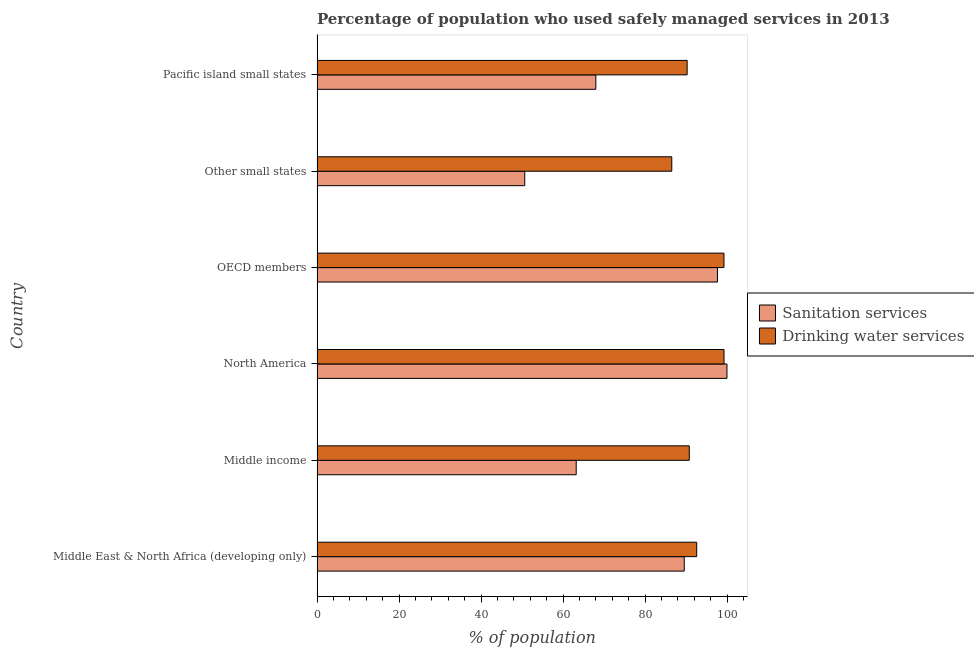How many different coloured bars are there?
Give a very brief answer. 2. How many groups of bars are there?
Your answer should be compact. 6. How many bars are there on the 5th tick from the top?
Keep it short and to the point. 2. What is the percentage of population who used drinking water services in Middle East & North Africa (developing only)?
Offer a terse response. 92.6. Across all countries, what is the maximum percentage of population who used sanitation services?
Your answer should be compact. 99.98. Across all countries, what is the minimum percentage of population who used drinking water services?
Your answer should be compact. 86.52. In which country was the percentage of population who used sanitation services maximum?
Give a very brief answer. North America. In which country was the percentage of population who used sanitation services minimum?
Ensure brevity in your answer.  Other small states. What is the total percentage of population who used drinking water services in the graph?
Your answer should be compact. 558.68. What is the difference between the percentage of population who used drinking water services in Middle income and that in Other small states?
Your response must be concise. 4.27. What is the difference between the percentage of population who used sanitation services in Middle income and the percentage of population who used drinking water services in Middle East & North Africa (developing only)?
Provide a short and direct response. -29.39. What is the average percentage of population who used sanitation services per country?
Offer a terse response. 78.18. What is the difference between the percentage of population who used drinking water services and percentage of population who used sanitation services in Middle East & North Africa (developing only)?
Make the answer very short. 3.03. What is the ratio of the percentage of population who used drinking water services in North America to that in Other small states?
Your answer should be very brief. 1.15. Is the percentage of population who used drinking water services in OECD members less than that in Other small states?
Keep it short and to the point. No. What is the difference between the highest and the second highest percentage of population who used drinking water services?
Offer a terse response. 0.02. What is the difference between the highest and the lowest percentage of population who used sanitation services?
Ensure brevity in your answer.  49.32. Is the sum of the percentage of population who used sanitation services in OECD members and Pacific island small states greater than the maximum percentage of population who used drinking water services across all countries?
Offer a terse response. Yes. What does the 2nd bar from the top in Middle income represents?
Offer a terse response. Sanitation services. What does the 2nd bar from the bottom in OECD members represents?
Offer a terse response. Drinking water services. How many countries are there in the graph?
Provide a short and direct response. 6. Does the graph contain any zero values?
Give a very brief answer. No. Does the graph contain grids?
Make the answer very short. No. Where does the legend appear in the graph?
Give a very brief answer. Center right. How are the legend labels stacked?
Provide a succinct answer. Vertical. What is the title of the graph?
Ensure brevity in your answer.  Percentage of population who used safely managed services in 2013. What is the label or title of the X-axis?
Offer a terse response. % of population. What is the label or title of the Y-axis?
Your answer should be very brief. Country. What is the % of population of Sanitation services in Middle East & North Africa (developing only)?
Your response must be concise. 89.57. What is the % of population of Drinking water services in Middle East & North Africa (developing only)?
Make the answer very short. 92.6. What is the % of population of Sanitation services in Middle income?
Offer a terse response. 63.21. What is the % of population in Drinking water services in Middle income?
Your response must be concise. 90.79. What is the % of population of Sanitation services in North America?
Offer a very short reply. 99.98. What is the % of population of Drinking water services in North America?
Ensure brevity in your answer.  99.26. What is the % of population of Sanitation services in OECD members?
Provide a succinct answer. 97.66. What is the % of population of Drinking water services in OECD members?
Give a very brief answer. 99.24. What is the % of population of Sanitation services in Other small states?
Your answer should be very brief. 50.66. What is the % of population of Drinking water services in Other small states?
Your response must be concise. 86.52. What is the % of population of Sanitation services in Pacific island small states?
Your answer should be compact. 68. What is the % of population of Drinking water services in Pacific island small states?
Give a very brief answer. 90.27. Across all countries, what is the maximum % of population in Sanitation services?
Keep it short and to the point. 99.98. Across all countries, what is the maximum % of population of Drinking water services?
Your response must be concise. 99.26. Across all countries, what is the minimum % of population of Sanitation services?
Give a very brief answer. 50.66. Across all countries, what is the minimum % of population of Drinking water services?
Provide a short and direct response. 86.52. What is the total % of population in Sanitation services in the graph?
Offer a very short reply. 469.07. What is the total % of population of Drinking water services in the graph?
Keep it short and to the point. 558.68. What is the difference between the % of population of Sanitation services in Middle East & North Africa (developing only) and that in Middle income?
Your answer should be very brief. 26.36. What is the difference between the % of population of Drinking water services in Middle East & North Africa (developing only) and that in Middle income?
Your answer should be compact. 1.81. What is the difference between the % of population of Sanitation services in Middle East & North Africa (developing only) and that in North America?
Offer a very short reply. -10.41. What is the difference between the % of population in Drinking water services in Middle East & North Africa (developing only) and that in North America?
Your answer should be compact. -6.66. What is the difference between the % of population of Sanitation services in Middle East & North Africa (developing only) and that in OECD members?
Provide a succinct answer. -8.1. What is the difference between the % of population of Drinking water services in Middle East & North Africa (developing only) and that in OECD members?
Provide a succinct answer. -6.64. What is the difference between the % of population in Sanitation services in Middle East & North Africa (developing only) and that in Other small states?
Provide a short and direct response. 38.91. What is the difference between the % of population of Drinking water services in Middle East & North Africa (developing only) and that in Other small states?
Provide a short and direct response. 6.08. What is the difference between the % of population of Sanitation services in Middle East & North Africa (developing only) and that in Pacific island small states?
Your response must be concise. 21.57. What is the difference between the % of population in Drinking water services in Middle East & North Africa (developing only) and that in Pacific island small states?
Your answer should be compact. 2.33. What is the difference between the % of population in Sanitation services in Middle income and that in North America?
Ensure brevity in your answer.  -36.77. What is the difference between the % of population in Drinking water services in Middle income and that in North America?
Provide a short and direct response. -8.47. What is the difference between the % of population of Sanitation services in Middle income and that in OECD members?
Your answer should be very brief. -34.45. What is the difference between the % of population of Drinking water services in Middle income and that in OECD members?
Keep it short and to the point. -8.46. What is the difference between the % of population of Sanitation services in Middle income and that in Other small states?
Ensure brevity in your answer.  12.55. What is the difference between the % of population of Drinking water services in Middle income and that in Other small states?
Your response must be concise. 4.27. What is the difference between the % of population of Sanitation services in Middle income and that in Pacific island small states?
Keep it short and to the point. -4.79. What is the difference between the % of population in Drinking water services in Middle income and that in Pacific island small states?
Keep it short and to the point. 0.52. What is the difference between the % of population in Sanitation services in North America and that in OECD members?
Ensure brevity in your answer.  2.32. What is the difference between the % of population of Drinking water services in North America and that in OECD members?
Provide a succinct answer. 0.02. What is the difference between the % of population in Sanitation services in North America and that in Other small states?
Provide a succinct answer. 49.32. What is the difference between the % of population of Drinking water services in North America and that in Other small states?
Offer a very short reply. 12.74. What is the difference between the % of population in Sanitation services in North America and that in Pacific island small states?
Your response must be concise. 31.98. What is the difference between the % of population in Drinking water services in North America and that in Pacific island small states?
Your answer should be compact. 8.99. What is the difference between the % of population of Sanitation services in OECD members and that in Other small states?
Offer a very short reply. 47. What is the difference between the % of population of Drinking water services in OECD members and that in Other small states?
Your response must be concise. 12.72. What is the difference between the % of population of Sanitation services in OECD members and that in Pacific island small states?
Offer a terse response. 29.66. What is the difference between the % of population in Drinking water services in OECD members and that in Pacific island small states?
Ensure brevity in your answer.  8.98. What is the difference between the % of population of Sanitation services in Other small states and that in Pacific island small states?
Ensure brevity in your answer.  -17.34. What is the difference between the % of population in Drinking water services in Other small states and that in Pacific island small states?
Offer a terse response. -3.74. What is the difference between the % of population in Sanitation services in Middle East & North Africa (developing only) and the % of population in Drinking water services in Middle income?
Ensure brevity in your answer.  -1.22. What is the difference between the % of population of Sanitation services in Middle East & North Africa (developing only) and the % of population of Drinking water services in North America?
Make the answer very short. -9.69. What is the difference between the % of population in Sanitation services in Middle East & North Africa (developing only) and the % of population in Drinking water services in OECD members?
Provide a succinct answer. -9.68. What is the difference between the % of population in Sanitation services in Middle East & North Africa (developing only) and the % of population in Drinking water services in Other small states?
Provide a short and direct response. 3.04. What is the difference between the % of population in Sanitation services in Middle East & North Africa (developing only) and the % of population in Drinking water services in Pacific island small states?
Keep it short and to the point. -0.7. What is the difference between the % of population of Sanitation services in Middle income and the % of population of Drinking water services in North America?
Offer a terse response. -36.05. What is the difference between the % of population in Sanitation services in Middle income and the % of population in Drinking water services in OECD members?
Provide a succinct answer. -36.03. What is the difference between the % of population of Sanitation services in Middle income and the % of population of Drinking water services in Other small states?
Give a very brief answer. -23.31. What is the difference between the % of population in Sanitation services in Middle income and the % of population in Drinking water services in Pacific island small states?
Give a very brief answer. -27.06. What is the difference between the % of population in Sanitation services in North America and the % of population in Drinking water services in OECD members?
Ensure brevity in your answer.  0.74. What is the difference between the % of population in Sanitation services in North America and the % of population in Drinking water services in Other small states?
Offer a very short reply. 13.46. What is the difference between the % of population in Sanitation services in North America and the % of population in Drinking water services in Pacific island small states?
Your answer should be compact. 9.71. What is the difference between the % of population of Sanitation services in OECD members and the % of population of Drinking water services in Other small states?
Ensure brevity in your answer.  11.14. What is the difference between the % of population of Sanitation services in OECD members and the % of population of Drinking water services in Pacific island small states?
Offer a terse response. 7.4. What is the difference between the % of population in Sanitation services in Other small states and the % of population in Drinking water services in Pacific island small states?
Give a very brief answer. -39.61. What is the average % of population of Sanitation services per country?
Make the answer very short. 78.18. What is the average % of population in Drinking water services per country?
Offer a very short reply. 93.11. What is the difference between the % of population of Sanitation services and % of population of Drinking water services in Middle East & North Africa (developing only)?
Offer a terse response. -3.03. What is the difference between the % of population in Sanitation services and % of population in Drinking water services in Middle income?
Offer a very short reply. -27.58. What is the difference between the % of population of Sanitation services and % of population of Drinking water services in North America?
Ensure brevity in your answer.  0.72. What is the difference between the % of population in Sanitation services and % of population in Drinking water services in OECD members?
Provide a short and direct response. -1.58. What is the difference between the % of population in Sanitation services and % of population in Drinking water services in Other small states?
Keep it short and to the point. -35.86. What is the difference between the % of population of Sanitation services and % of population of Drinking water services in Pacific island small states?
Your response must be concise. -22.27. What is the ratio of the % of population in Sanitation services in Middle East & North Africa (developing only) to that in Middle income?
Provide a short and direct response. 1.42. What is the ratio of the % of population in Sanitation services in Middle East & North Africa (developing only) to that in North America?
Ensure brevity in your answer.  0.9. What is the ratio of the % of population in Drinking water services in Middle East & North Africa (developing only) to that in North America?
Your answer should be compact. 0.93. What is the ratio of the % of population in Sanitation services in Middle East & North Africa (developing only) to that in OECD members?
Your response must be concise. 0.92. What is the ratio of the % of population in Drinking water services in Middle East & North Africa (developing only) to that in OECD members?
Provide a succinct answer. 0.93. What is the ratio of the % of population in Sanitation services in Middle East & North Africa (developing only) to that in Other small states?
Provide a succinct answer. 1.77. What is the ratio of the % of population of Drinking water services in Middle East & North Africa (developing only) to that in Other small states?
Ensure brevity in your answer.  1.07. What is the ratio of the % of population of Sanitation services in Middle East & North Africa (developing only) to that in Pacific island small states?
Provide a succinct answer. 1.32. What is the ratio of the % of population in Drinking water services in Middle East & North Africa (developing only) to that in Pacific island small states?
Your response must be concise. 1.03. What is the ratio of the % of population of Sanitation services in Middle income to that in North America?
Your answer should be very brief. 0.63. What is the ratio of the % of population of Drinking water services in Middle income to that in North America?
Keep it short and to the point. 0.91. What is the ratio of the % of population of Sanitation services in Middle income to that in OECD members?
Ensure brevity in your answer.  0.65. What is the ratio of the % of population of Drinking water services in Middle income to that in OECD members?
Your response must be concise. 0.91. What is the ratio of the % of population of Sanitation services in Middle income to that in Other small states?
Your answer should be very brief. 1.25. What is the ratio of the % of population in Drinking water services in Middle income to that in Other small states?
Ensure brevity in your answer.  1.05. What is the ratio of the % of population in Sanitation services in Middle income to that in Pacific island small states?
Ensure brevity in your answer.  0.93. What is the ratio of the % of population in Sanitation services in North America to that in OECD members?
Provide a succinct answer. 1.02. What is the ratio of the % of population in Drinking water services in North America to that in OECD members?
Your answer should be compact. 1. What is the ratio of the % of population in Sanitation services in North America to that in Other small states?
Offer a terse response. 1.97. What is the ratio of the % of population of Drinking water services in North America to that in Other small states?
Offer a very short reply. 1.15. What is the ratio of the % of population of Sanitation services in North America to that in Pacific island small states?
Make the answer very short. 1.47. What is the ratio of the % of population of Drinking water services in North America to that in Pacific island small states?
Offer a terse response. 1.1. What is the ratio of the % of population in Sanitation services in OECD members to that in Other small states?
Offer a very short reply. 1.93. What is the ratio of the % of population in Drinking water services in OECD members to that in Other small states?
Make the answer very short. 1.15. What is the ratio of the % of population of Sanitation services in OECD members to that in Pacific island small states?
Offer a very short reply. 1.44. What is the ratio of the % of population in Drinking water services in OECD members to that in Pacific island small states?
Your answer should be very brief. 1.1. What is the ratio of the % of population of Sanitation services in Other small states to that in Pacific island small states?
Offer a terse response. 0.74. What is the ratio of the % of population of Drinking water services in Other small states to that in Pacific island small states?
Offer a terse response. 0.96. What is the difference between the highest and the second highest % of population in Sanitation services?
Your answer should be very brief. 2.32. What is the difference between the highest and the second highest % of population in Drinking water services?
Provide a short and direct response. 0.02. What is the difference between the highest and the lowest % of population in Sanitation services?
Give a very brief answer. 49.32. What is the difference between the highest and the lowest % of population in Drinking water services?
Your response must be concise. 12.74. 